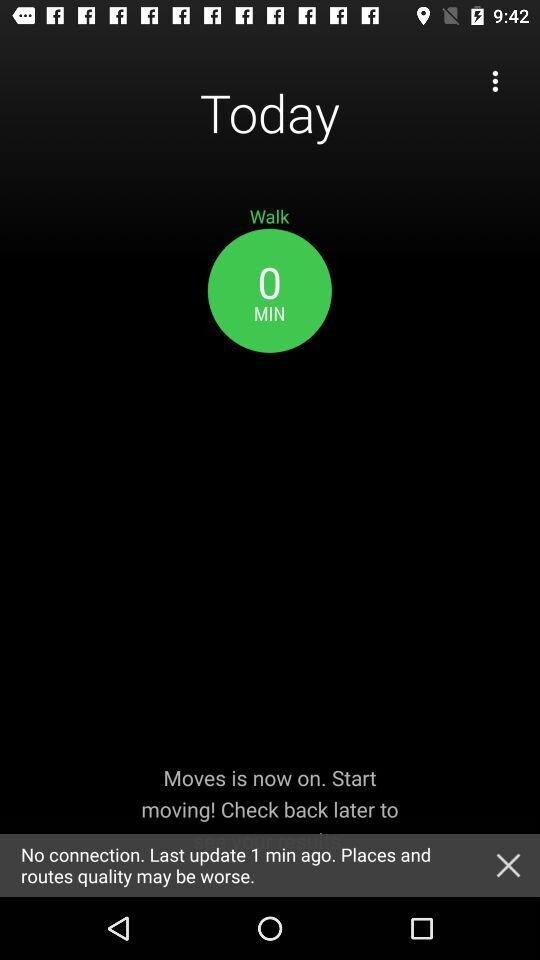What is the time duration of the walk? The time duration is 0 minutes. 